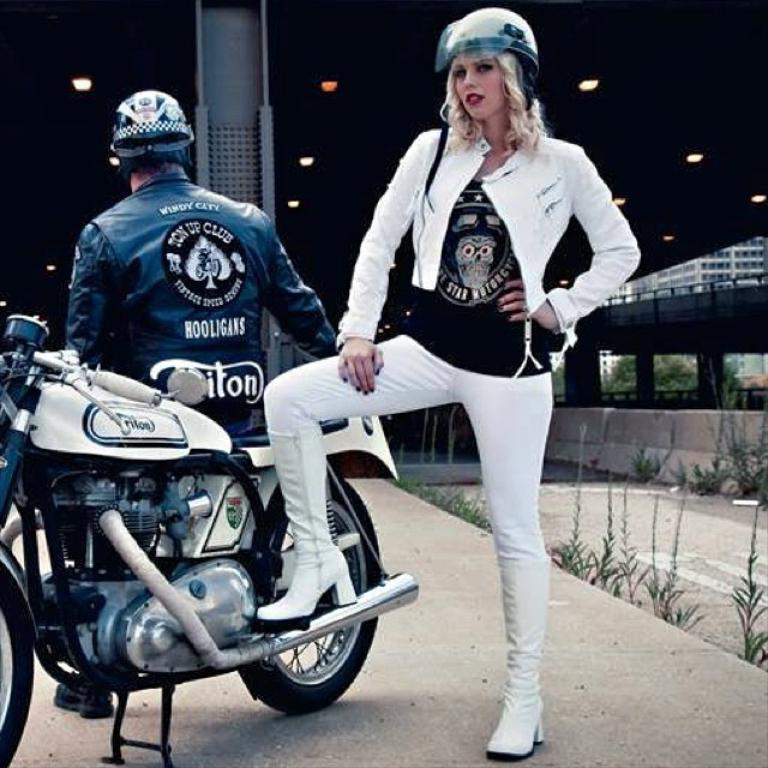What is the woman doing in the image? The woman is standing beside a motorbike. What is the man doing in the image? The man is sitting on a motorbike. What can be seen in the background of the image? There is a building, a tree, plants, and light visible in the background of the image. What type of lipstick is the woman wearing in the image? There is no indication of the woman wearing lipstick in the image. What country is the motorbike from in the image? The image does not provide information about the origin or country of the motorbike. 